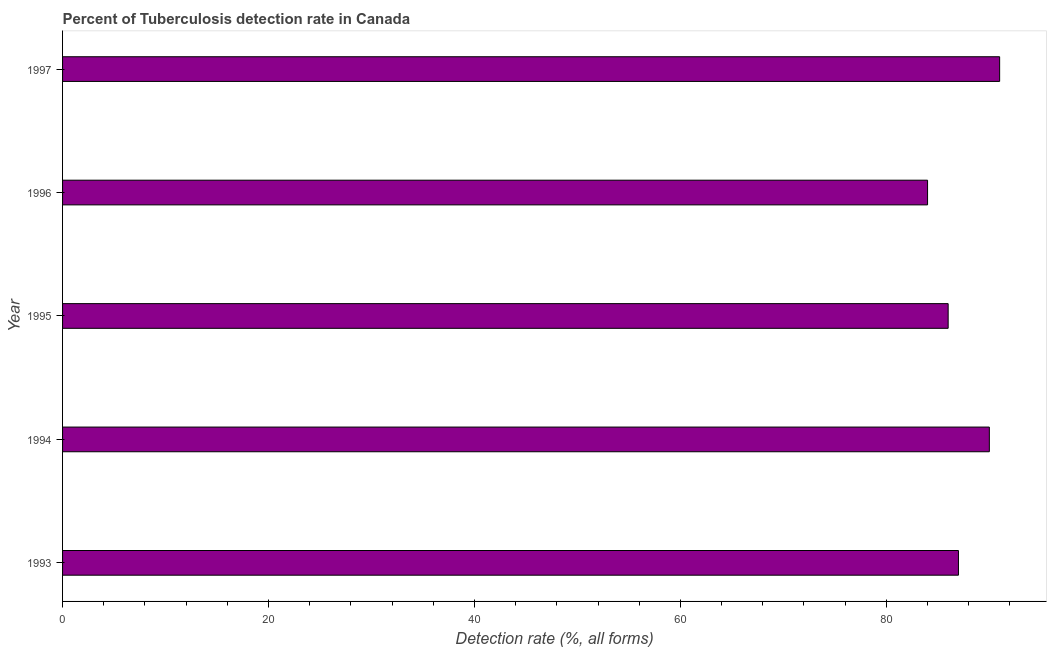Does the graph contain grids?
Provide a succinct answer. No. What is the title of the graph?
Offer a terse response. Percent of Tuberculosis detection rate in Canada. What is the label or title of the X-axis?
Your answer should be very brief. Detection rate (%, all forms). What is the label or title of the Y-axis?
Your answer should be very brief. Year. Across all years, what is the maximum detection rate of tuberculosis?
Your response must be concise. 91. In which year was the detection rate of tuberculosis minimum?
Keep it short and to the point. 1996. What is the sum of the detection rate of tuberculosis?
Your response must be concise. 438. What is the difference between the detection rate of tuberculosis in 1994 and 1997?
Your answer should be very brief. -1. What is the average detection rate of tuberculosis per year?
Ensure brevity in your answer.  87. What is the median detection rate of tuberculosis?
Give a very brief answer. 87. In how many years, is the detection rate of tuberculosis greater than 20 %?
Your answer should be very brief. 5. Do a majority of the years between 1994 and 1996 (inclusive) have detection rate of tuberculosis greater than 64 %?
Provide a succinct answer. Yes. Is the detection rate of tuberculosis in 1993 less than that in 1995?
Make the answer very short. No. What is the difference between the highest and the second highest detection rate of tuberculosis?
Make the answer very short. 1. Is the sum of the detection rate of tuberculosis in 1993 and 1994 greater than the maximum detection rate of tuberculosis across all years?
Your answer should be compact. Yes. What is the difference between the highest and the lowest detection rate of tuberculosis?
Make the answer very short. 7. How many bars are there?
Provide a succinct answer. 5. How many years are there in the graph?
Offer a very short reply. 5. Are the values on the major ticks of X-axis written in scientific E-notation?
Make the answer very short. No. What is the Detection rate (%, all forms) in 1993?
Offer a very short reply. 87. What is the Detection rate (%, all forms) of 1994?
Make the answer very short. 90. What is the Detection rate (%, all forms) in 1996?
Your answer should be compact. 84. What is the Detection rate (%, all forms) in 1997?
Provide a short and direct response. 91. What is the difference between the Detection rate (%, all forms) in 1993 and 1994?
Your answer should be compact. -3. What is the difference between the Detection rate (%, all forms) in 1993 and 1996?
Offer a very short reply. 3. What is the difference between the Detection rate (%, all forms) in 1993 and 1997?
Your answer should be compact. -4. What is the difference between the Detection rate (%, all forms) in 1996 and 1997?
Offer a very short reply. -7. What is the ratio of the Detection rate (%, all forms) in 1993 to that in 1994?
Ensure brevity in your answer.  0.97. What is the ratio of the Detection rate (%, all forms) in 1993 to that in 1995?
Ensure brevity in your answer.  1.01. What is the ratio of the Detection rate (%, all forms) in 1993 to that in 1996?
Give a very brief answer. 1.04. What is the ratio of the Detection rate (%, all forms) in 1993 to that in 1997?
Provide a short and direct response. 0.96. What is the ratio of the Detection rate (%, all forms) in 1994 to that in 1995?
Make the answer very short. 1.05. What is the ratio of the Detection rate (%, all forms) in 1994 to that in 1996?
Your answer should be very brief. 1.07. What is the ratio of the Detection rate (%, all forms) in 1995 to that in 1996?
Provide a short and direct response. 1.02. What is the ratio of the Detection rate (%, all forms) in 1995 to that in 1997?
Provide a succinct answer. 0.94. What is the ratio of the Detection rate (%, all forms) in 1996 to that in 1997?
Give a very brief answer. 0.92. 